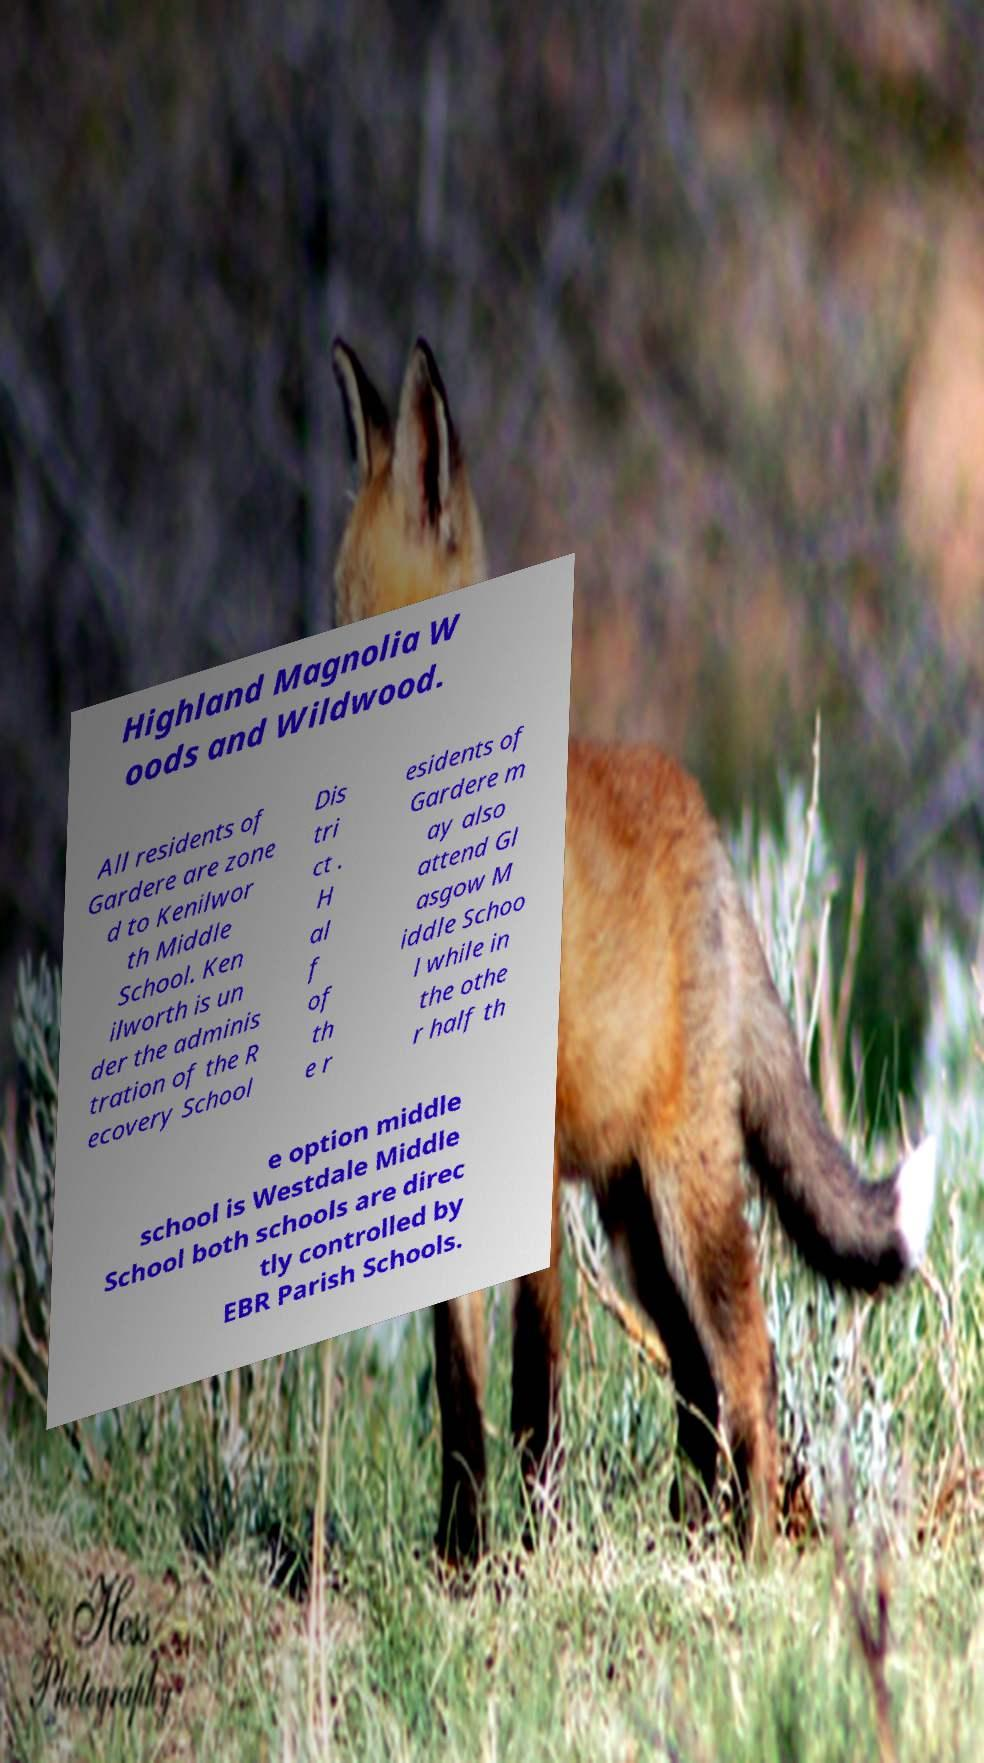Could you assist in decoding the text presented in this image and type it out clearly? Highland Magnolia W oods and Wildwood. All residents of Gardere are zone d to Kenilwor th Middle School. Ken ilworth is un der the adminis tration of the R ecovery School Dis tri ct . H al f of th e r esidents of Gardere m ay also attend Gl asgow M iddle Schoo l while in the othe r half th e option middle school is Westdale Middle School both schools are direc tly controlled by EBR Parish Schools. 